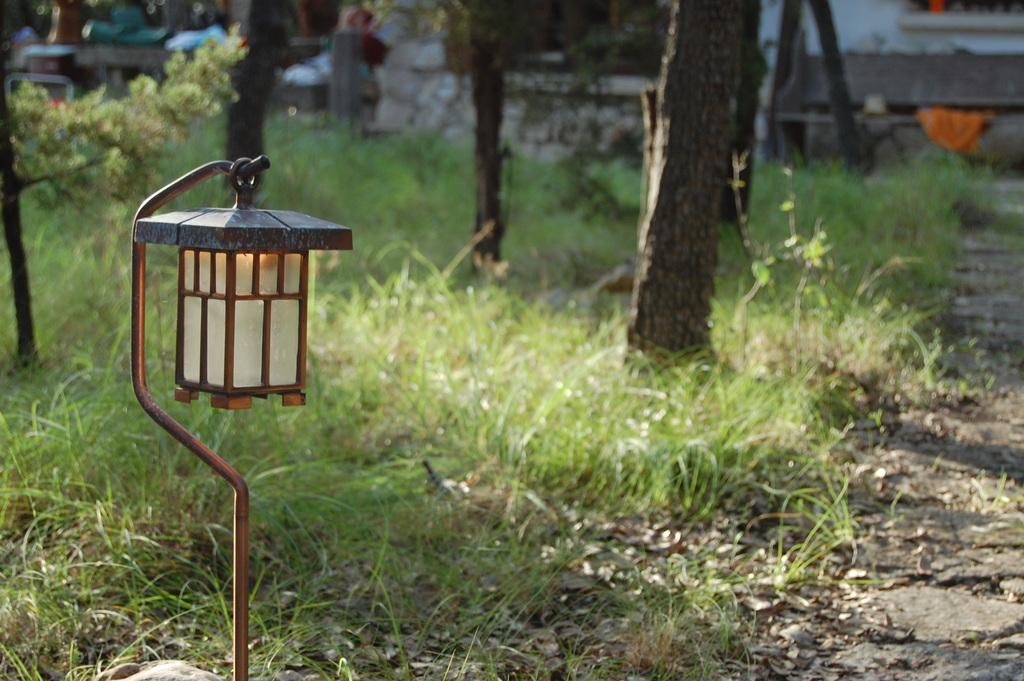What is attached to the iron rod in the image? There is a light attached to an iron rod in the image. Where is the light located in relation to the image? The light is towards the left side of the image. What type of vegetation is visible at the bottom of the image? There is grass at the bottom of the image. What else can be seen growing in the image? There are plants visible in the image. What type of structure is present in the image? There is a building in the image. How many women are seen eating crackers while watching the channel in the image? There are no women or channels present in the image; it features a light, grass, plants, and a building. 